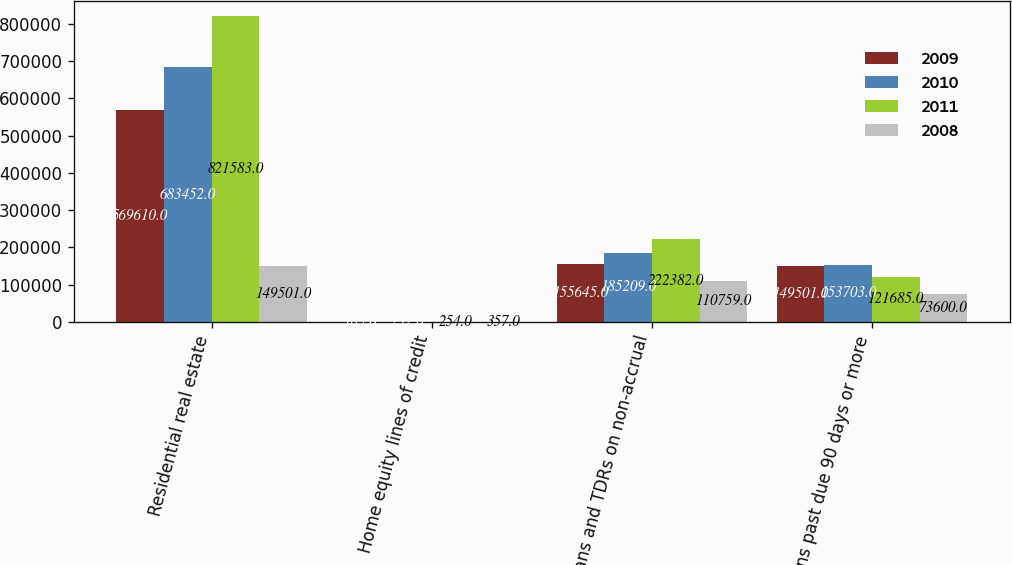<chart> <loc_0><loc_0><loc_500><loc_500><stacked_bar_chart><ecel><fcel>Residential real estate<fcel>Home equity lines of credit<fcel>Loans and TDRs on non-accrual<fcel>Loans past due 90 days or more<nl><fcel>2009<fcel>569610<fcel>183<fcel>155645<fcel>149501<nl><fcel>2010<fcel>683452<fcel>232<fcel>185209<fcel>153703<nl><fcel>2011<fcel>821583<fcel>254<fcel>222382<fcel>121685<nl><fcel>2008<fcel>149501<fcel>357<fcel>110759<fcel>73600<nl></chart> 